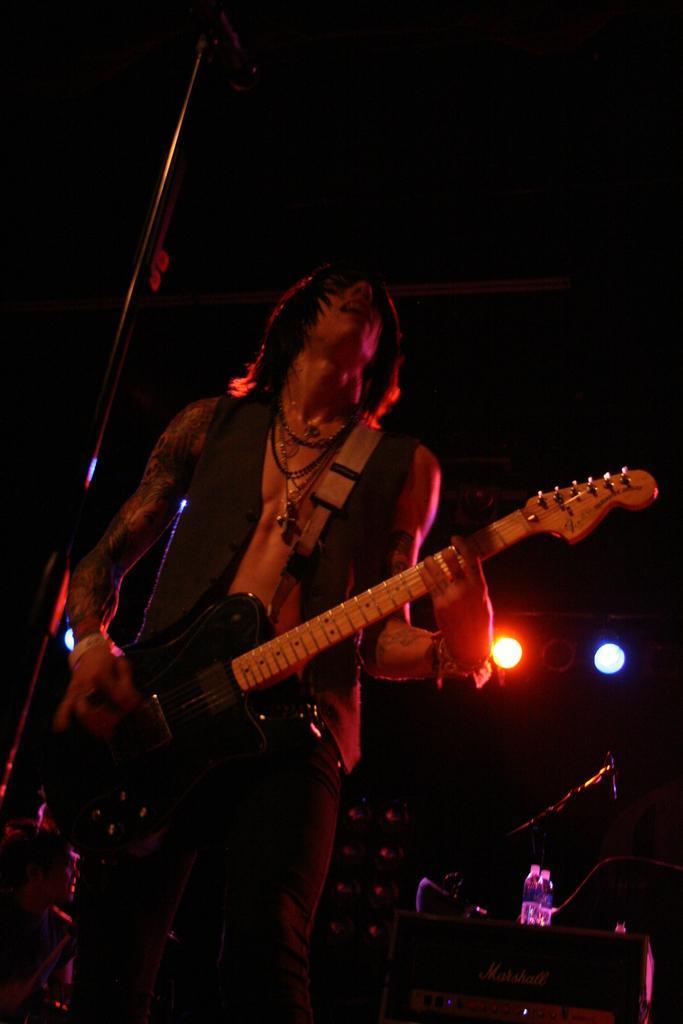Could you give a brief overview of what you see in this image? This is the picture of a person which short hair holding the guitar and standing in front of the mic and behind him there are some speakers, bottles and some lights. 